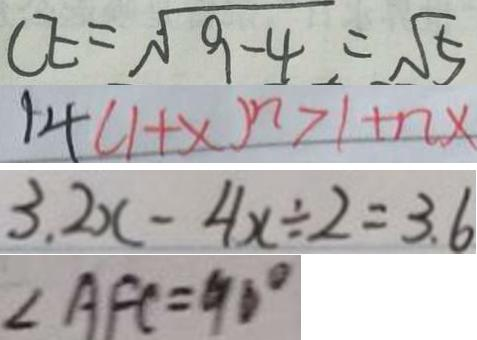Convert formula to latex. <formula><loc_0><loc_0><loc_500><loc_500>C E = \sqrt { 9 - 4 } = \sqrt { 5 } 
 1 4 ( 1 + x ) ^ { n } > 1 + n x 
 3 . 2 x - 4 x \div 2 = 3 . 6 
 \angle A F C = 9 0 ^ { \circ }</formula> 